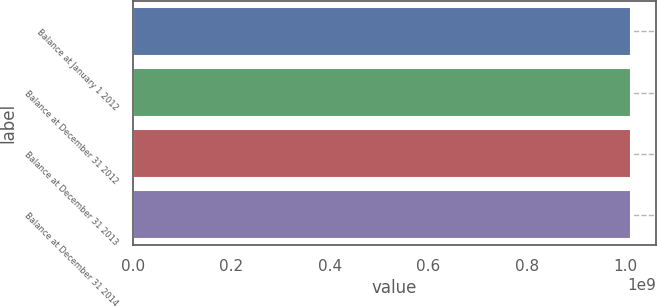<chart> <loc_0><loc_0><loc_500><loc_500><bar_chart><fcel>Balance at January 1 2012<fcel>Balance at December 31 2012<fcel>Balance at December 31 2013<fcel>Balance at December 31 2014<nl><fcel>1.01226e+09<fcel>1.01226e+09<fcel>1.01226e+09<fcel>1.01226e+09<nl></chart> 